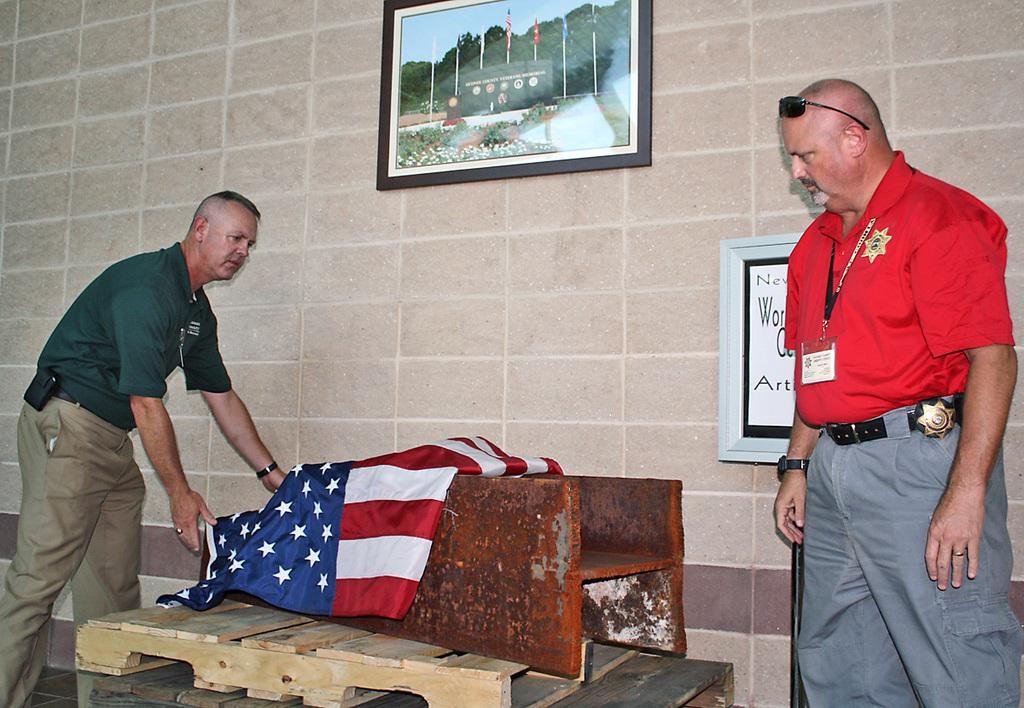Please provide a concise description of this image. In this image I can see two persons standing and I can see a person is holding a flag. I can see few wooden objects in between the persons and in the background I can see the wall and two photo frames attached to the wall. 